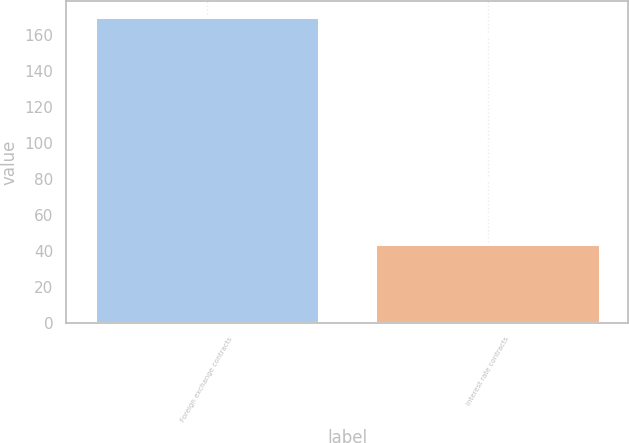<chart> <loc_0><loc_0><loc_500><loc_500><bar_chart><fcel>Foreign exchange contracts<fcel>Interest rate contracts<nl><fcel>170<fcel>44<nl></chart> 